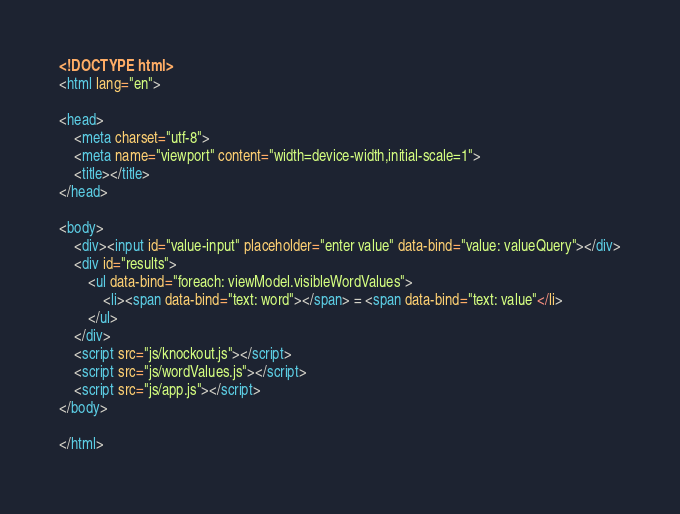<code> <loc_0><loc_0><loc_500><loc_500><_HTML_><!DOCTYPE html>
<html lang="en">

<head>
    <meta charset="utf-8">
    <meta name="viewport" content="width=device-width,initial-scale=1">
    <title></title>
</head>

<body>
    <div><input id="value-input" placeholder="enter value" data-bind="value: valueQuery"></div>
    <div id="results">
        <ul data-bind="foreach: viewModel.visibleWordValues">
            <li><span data-bind="text: word"></span> = <span data-bind="text: value"</li>
        </ul>
    </div>
    <script src="js/knockout.js"></script>
    <script src="js/wordValues.js"></script>
    <script src="js/app.js"></script>
</body>

</html>
</code> 